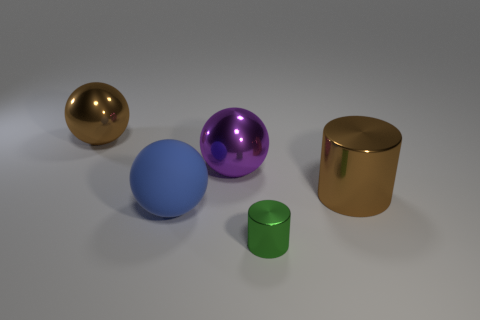Subtract all shiny spheres. How many spheres are left? 1 Add 2 big blue things. How many objects exist? 7 Subtract all balls. How many objects are left? 2 Subtract all red spheres. Subtract all green cubes. How many spheres are left? 3 Subtract all big shiny cylinders. Subtract all big balls. How many objects are left? 1 Add 4 brown metal cylinders. How many brown metal cylinders are left? 5 Add 2 tiny cyan metallic cubes. How many tiny cyan metallic cubes exist? 2 Subtract 0 gray balls. How many objects are left? 5 